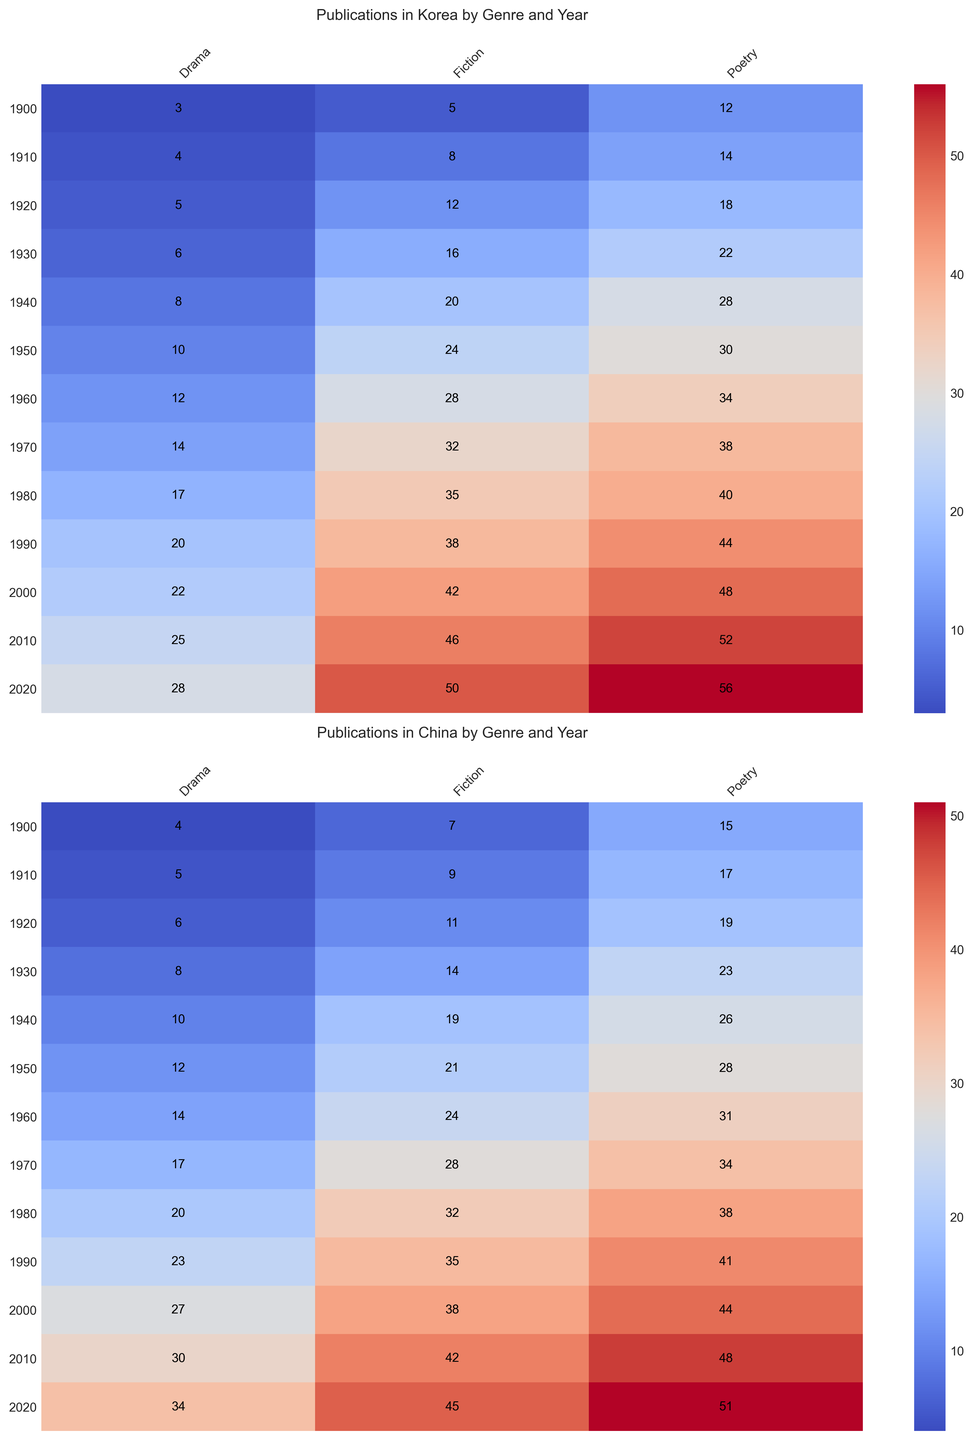What year had the highest number of Fiction publications in Korea? Look at the heatmap for Korea and find the year with the darkest shade corresponding to Fiction. This will be the year with the highest number of publications.
Answer: 2020 How does the number of Drama publications in China in 1940 compare to those in Korea the same year? Compare the corresponding cells in the China and Korea heatmaps for the year 1940 under Drama. In China, the number is 10 and in Korea, it is 8.
Answer: China had more publications What is the difference in Poetry publications between Korea and China in 2010? Locate the cell for Poetry in 2010 in both the Korea and China heatmaps and calculate the difference: 52 (Korea) - 48 (China).
Answer: 4 Which genre experienced the largest increase in publications in Korea from 1900 to 2000? Compare the publication numbers in 1900 and 2000 for each genre (Fiction, Poetry, Drama). For Fiction, the increase is 42-5=37, for Poetry 48-12=36, and for Drama 22-3=19. Fiction has the largest increase.
Answer: Fiction What is the average number of Poetry publications in Korea across the decades shown in the heatmap? Sum the Poetry publication numbers for each decade for Korea and divide by the number of decades: (12+14+18+22+28+30+34+38+40+44+48+52+56)/13.
Answer: 33.5 In which year do Fiction publications in China first surpass those in Korea? Check the Fiction cells for each year and find the first instance where the value for China is greater than that for Korea. This first happens in 1910 where China has 9 and Korea has 8.
Answer: 1910 Is there any year where the number of Drama publications in Korea equaled those in China? Inspect the heatmaps side by side and find matching values in the Drama columns. The values for both countries never match in any given year.
Answer: No Which decade shows the highest increase in Poetry publications for China compared to the previous decade? Calculate the decade-over-decade increases for Poetry in China: 15-0=15 (pre-1900 to 1900), (17-15)=2, (19-17)=2, (23-19)=4, (26-23)=3, (28-26)=2, (31-28)=3, (34-31)=3, (38-34)=4, (41-38)=3, (44-41)=3, (48-44)=4, (51-48)=3. The highest increase happens initially from 0 to 15 before 1900, indicating a significant jump in the beginning.
Answer: Pre-1900 to 1900 Between 1950 and 1970 in Korea, which genre had the largest total number of publications? Sum up the numbers for each genre for the years 1950, 1960, and 1970. For Fiction: 24+28+32=84, for Poetry: 30+34+38=102, for Drama: 10+12+14=36. Poetry has the largest total.
Answer: Poetry 